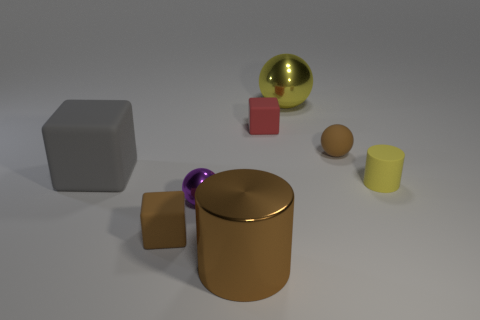There is a matte cube that is the same color as the shiny cylinder; what is its size?
Your response must be concise. Small. How many rubber objects are either tiny brown cubes or brown balls?
Make the answer very short. 2. What is the material of the tiny thing that is both behind the big gray rubber block and to the left of the yellow ball?
Keep it short and to the point. Rubber. Are there any tiny yellow cylinders that are in front of the metallic sphere that is on the left side of the shiny object behind the yellow matte cylinder?
Provide a short and direct response. No. Is there anything else that has the same material as the small purple thing?
Provide a short and direct response. Yes. There is a tiny purple object that is the same material as the large ball; what shape is it?
Offer a very short reply. Sphere. Are there fewer rubber blocks that are in front of the tiny yellow matte object than small rubber blocks in front of the big brown metal cylinder?
Keep it short and to the point. No. What number of small objects are purple things or red things?
Give a very brief answer. 2. There is a shiny object that is behind the tiny red rubber cube; does it have the same shape as the large metallic object that is in front of the small brown cube?
Make the answer very short. No. There is a rubber cube that is on the right side of the small block that is in front of the brown matte thing to the right of the red matte block; what size is it?
Offer a terse response. Small. 